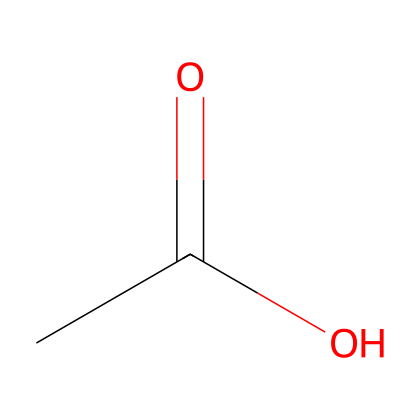What is the molecular formula of this compound? The SMILES representation CC(=O)O indicates that the compound consists of 2 carbon atoms, 4 hydrogen atoms, and 2 oxygen atoms, which gives us the formula C2H4O2.
Answer: C2H4O2 How many oxygen atoms are in this molecule? By analyzing the SMILES CC(=O)O, we can see there are 2 oxygen atoms in the structure.
Answer: 2 What type of functional group is present in acetic acid? The functional group visible from the structure is the carboxyl group (–COOH), which is characteristic of acids.
Answer: carboxyl What is the pH of a typical vinegar solution containing acetic acid? Vinegar usually has a pH around 2 to 3 due to the presence of acetic acid, which is a weak acid.
Answer: 2 to 3 How does the structure of acetic acid classify it in terms of acid strength? Acetic acid has a relatively low degree of ionization in water compared to strong acids, which classifies it as a weak acid.
Answer: weak acid What is the total number of hydrogen atoms in this acetic acid molecule? In the SMILES structure, the total number of hydrogen atoms is 4, including those attached to the carbon and the hydrogen of the carboxyl group.
Answer: 4 